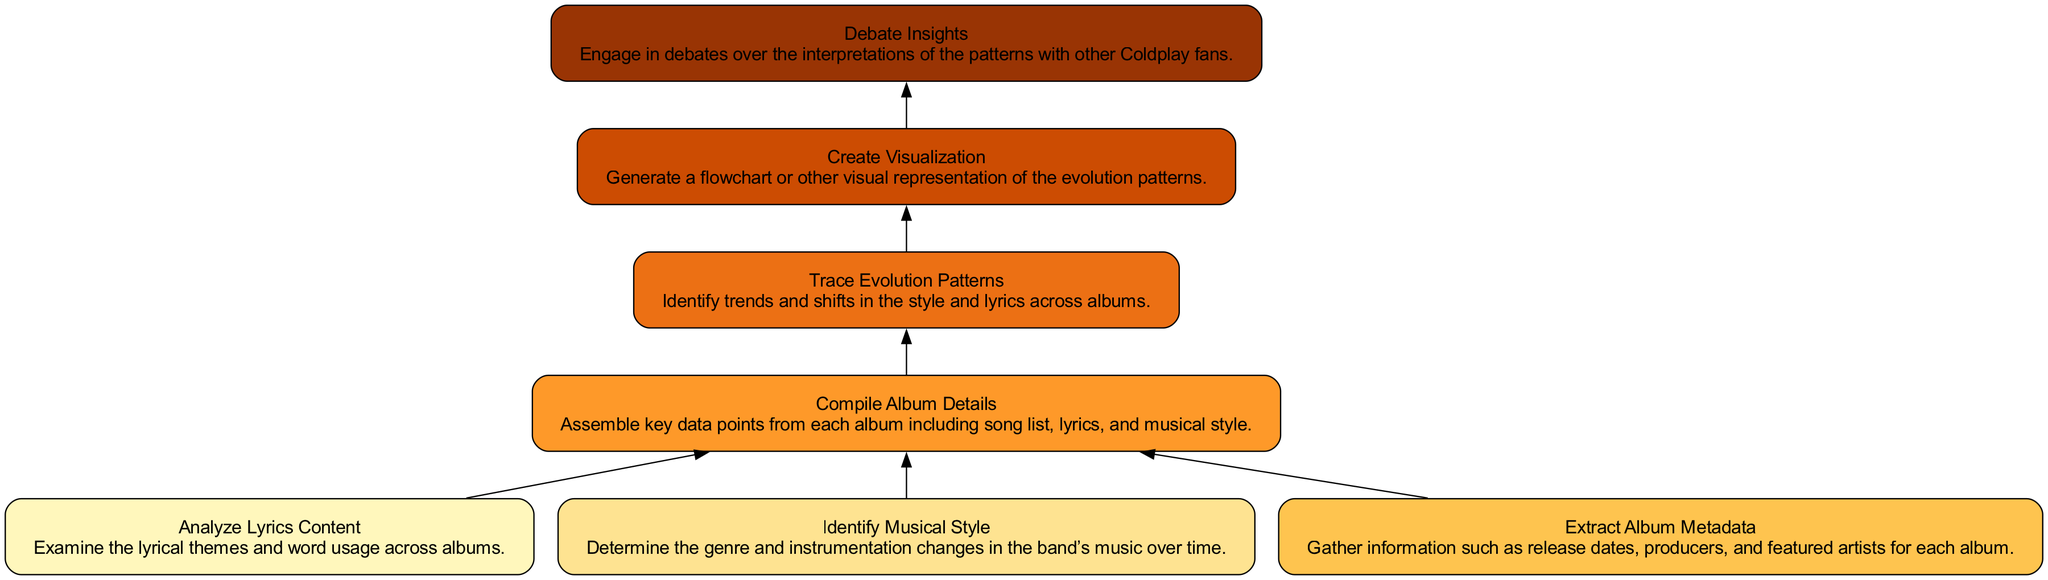What is the topmost node in the diagram? The diagram is structured as a flowchart with nodes flowing from bottom to top. The topmost node would be the last step in the process, which is "Debate Insights".
Answer: Debate Insights How many nodes are present in the diagram? To find the total number of nodes, we can count each of the distinct elements listed in the data. There are seven nodes in total.
Answer: 7 Which node relies on the "Compile Album Details" node? The node that is dependent on "Compile Album Details" is "Trace Evolution Patterns", as indicated by its dependencies listed in the diagram.
Answer: Trace Evolution Patterns What is the role of the "Create Visualization" node? "Create Visualization" is responsible for generating a visual representation of the evolution patterns identified in the previous step. It summarizes the trends and findings into a visual format.
Answer: Generate a flowchart or other visual representation of the evolution patterns Which step comes right before the "Trace Evolution Patterns" node? The step immediately preceding "Trace Evolution Patterns" is "Compile Album Details", which provides the necessary information to identify trends and shifts in style and lyrics.
Answer: Compile Album Details What is the primary focus of the "Analyze Lyrics Content" node? The primary focus of this node is to examine the lyrical themes and word usage across the Coldplay albums to understand how they have evolved over time.
Answer: Examine the lyrical themes and word usage across albums How many dependencies does the "Create Visualization" node have? The "Create Visualization" node has only one dependency, which is the "Trace Evolution Patterns" node.
Answer: 1 Which two nodes have no dependencies? The nodes that do not rely on any previous nodes are "Analyze Lyrics Content" and "Identify Musical Style", as they are the initial steps in the process before any compilation or analysis occurs.
Answer: Analyze Lyrics Content, Identify Musical Style What happens after the "Debate Insights" node? After "Debate Insights", there are no further nodes in the flowchart as it's the final step indicating that after generating insights, the next action is engaging in debate.
Answer: None 